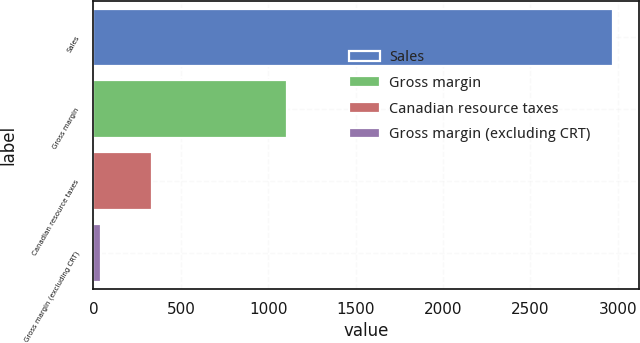Convert chart. <chart><loc_0><loc_0><loc_500><loc_500><bar_chart><fcel>Sales<fcel>Gross margin<fcel>Canadian resource taxes<fcel>Gross margin (excluding CRT)<nl><fcel>2973.2<fcel>1104.9<fcel>336.47<fcel>43.5<nl></chart> 